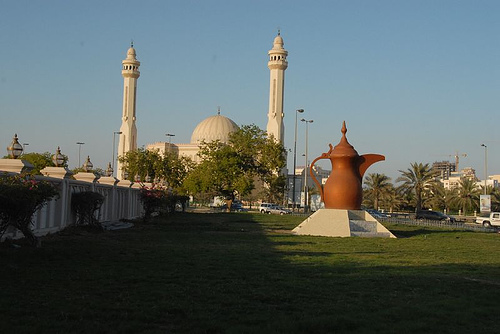<image>
Can you confirm if the grass is on the car? No. The grass is not positioned on the car. They may be near each other, but the grass is not supported by or resting on top of the car. Is the teapot in front of the mosque? Yes. The teapot is positioned in front of the mosque, appearing closer to the camera viewpoint. 